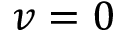Convert formula to latex. <formula><loc_0><loc_0><loc_500><loc_500>v = 0</formula> 